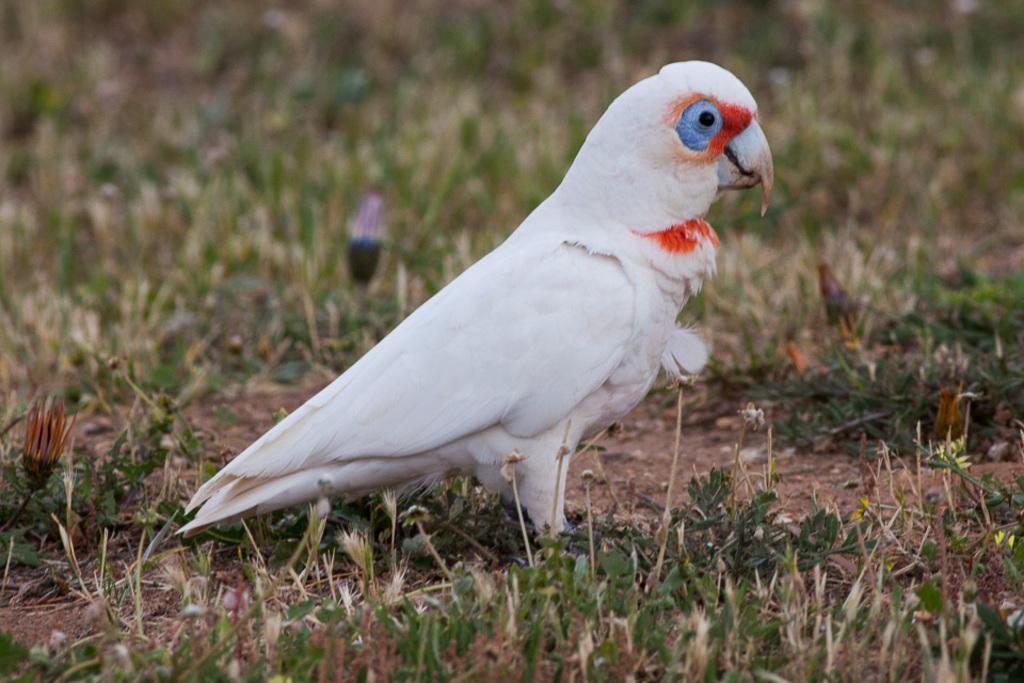In one or two sentences, can you explain what this image depicts? There is a white color bird standing on the grass on the ground near plants which are having flowers. And the background is blurred. 